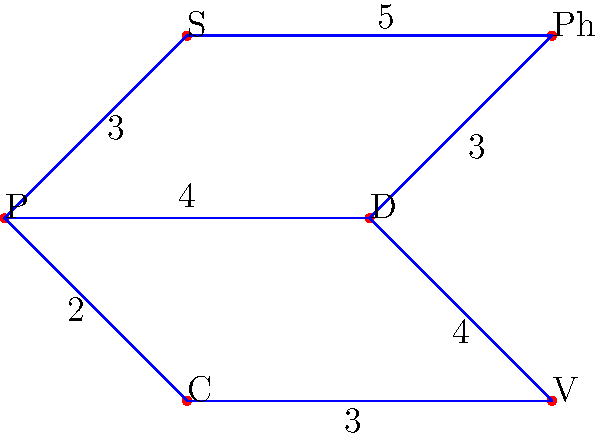In a mixed-media project, you need to connect different artistic mediums efficiently. The graph represents the compatibility between mediums, where vertices are mediums (P: Painting, S: Sculpture, D: Digital art, C: Collage, Ph: Photography, V: Video) and edge weights represent the effort required to combine them. What is the minimum total effort required to connect all mediums in the most efficient way? To find the most efficient way to connect all mediums with minimum total effort, we need to find the Minimum Spanning Tree (MST) of the graph. We can use Kruskal's algorithm to solve this problem:

1. Sort all edges by weight in ascending order:
   (P,C): 2
   (P,S): 3
   (D,Ph): 3
   (C,V): 3
   (P,D): 4
   (D,V): 4
   (S,Ph): 5

2. Start with an empty set of edges and add edges one by one, ensuring no cycles are formed:
   - Add (P,C): 2
   - Add (P,S): 3
   - Add (D,Ph): 3
   - Add (C,V): 3
   - Add (P,D): 4

3. We now have 5 edges connecting all 6 vertices, forming the MST.

4. Calculate the total effort by summing the weights of the selected edges:
   2 + 3 + 3 + 3 + 4 = 15

Therefore, the minimum total effort required to connect all mediums in the most efficient way is 15.
Answer: 15 